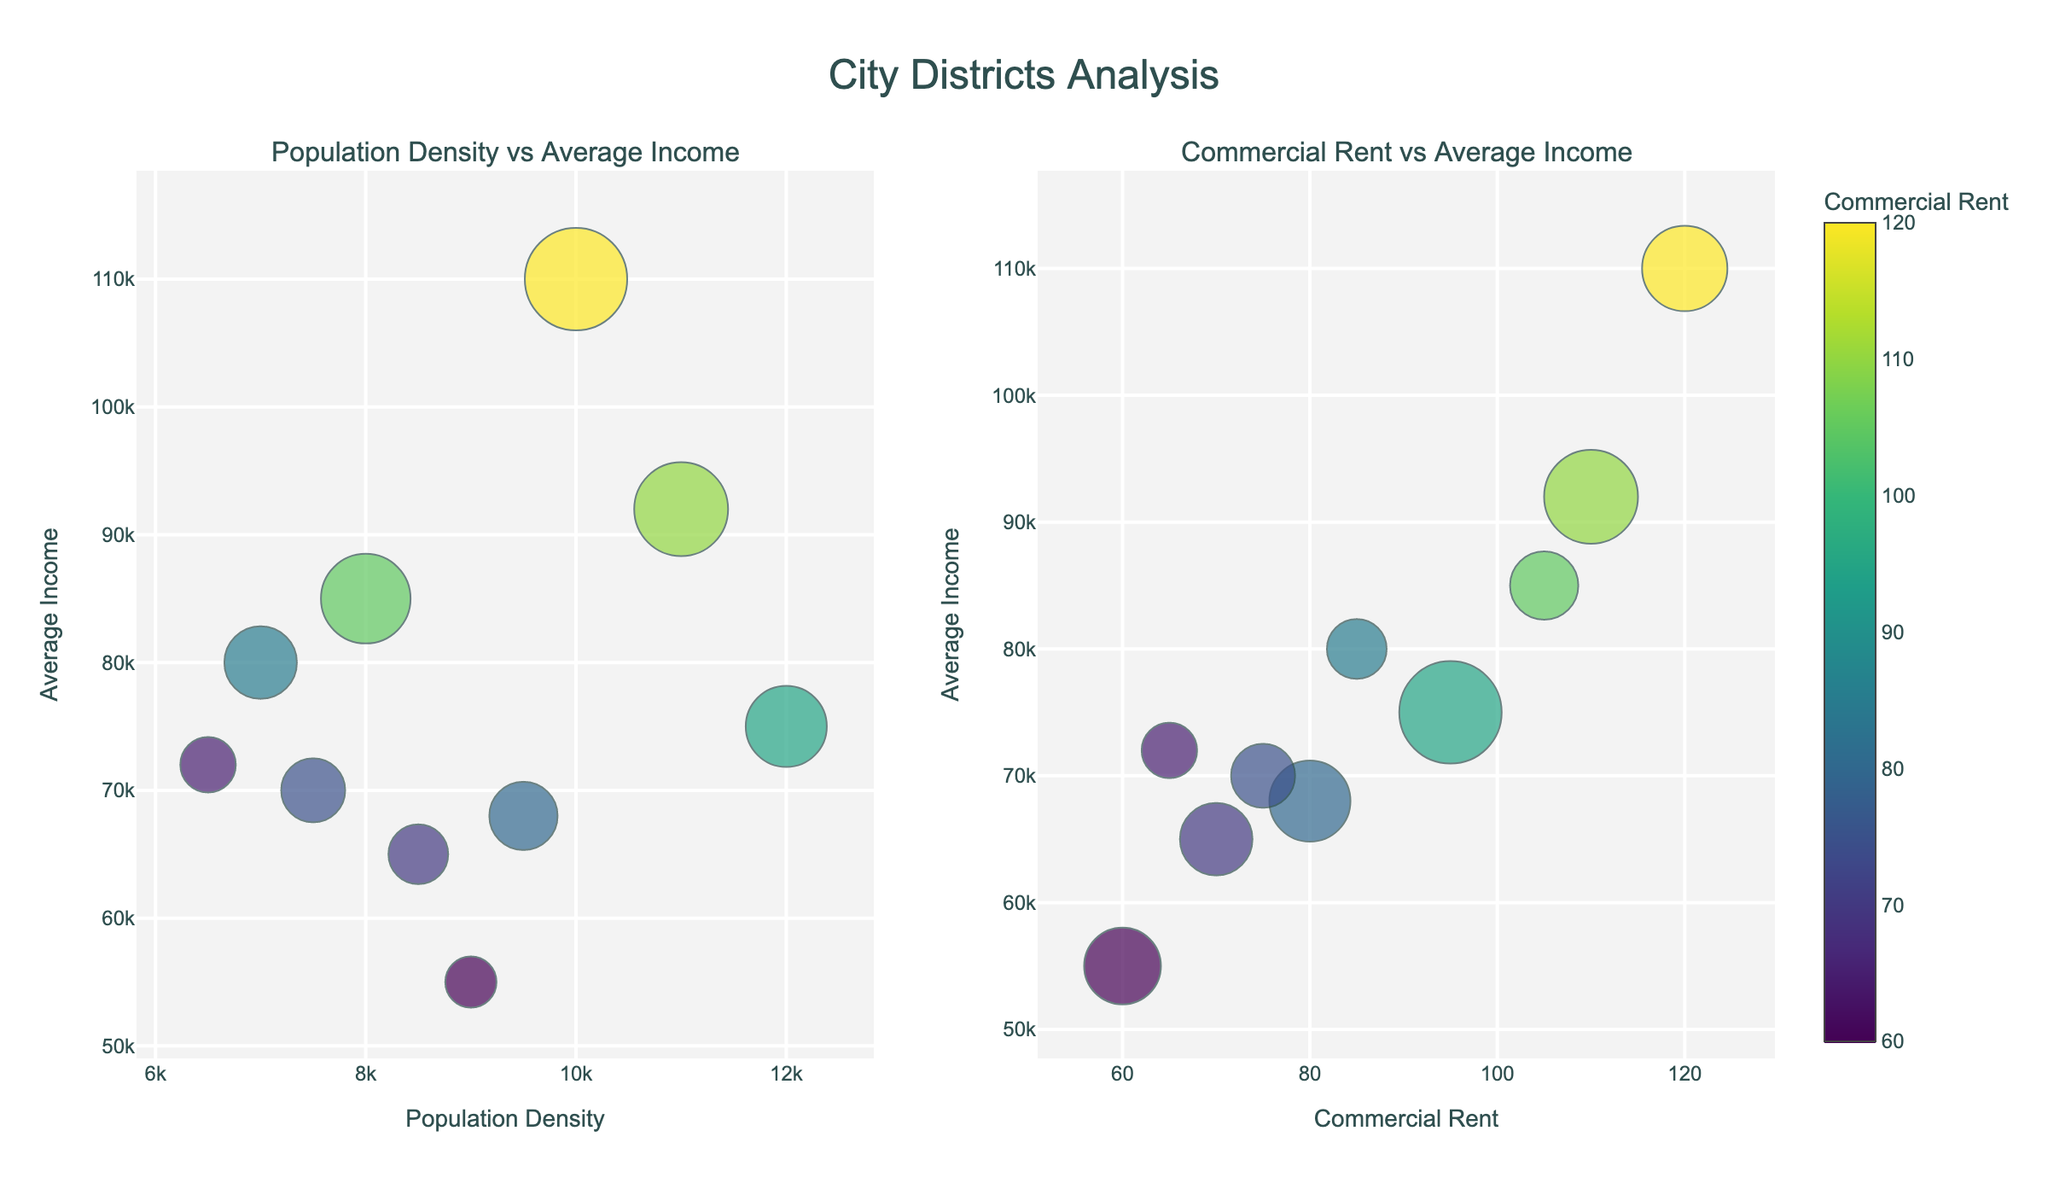what does the title of the figure say? The title is located at the top center of the figure. It provides context for the visualizations present. The title indicates that the figure is an analysis of various city districts.
Answer: City Districts Analysis How many subplots are there in the figure? Observing the layout, there are two distinct plots side by side within the figure.
Answer: 2 Which district has the highest population density? By examining the x-axis of the first subplot for the maximum population density value, we can see which data point is labeled as "District." The point with the highest x-axis value and the label "Downtown" corresponds to the highest population density.
Answer: Downtown Which subplot shows the relationship between Commercial Rent and Average Income? The labels for the axes are key. By observing the subplot where the x-axis is titled "Commercial Rent" and y-axis is titled "Average Income," you can identify it as the second subplot (right side).
Answer: The second subplot What is the average income for the Financial District? Hovering over or identifying the specific data point labeled "Financial District" in either subplot and checking the y-axis value will show the average income.
Answer: 92,000 Which district has the smallest bubble size in the first subplot, and what does this indicate about its Commercial Rent? Smaller bubble sizes in the first subplot represent lower commercial rent. By identifying the smallest bubble and its associated district label, we find that Long Island City has the smallest bubble size, indicating it has the lowest Commercial Rent.
Answer: Long Island City How does the Average Income in Chelsea compare to that in Williamsburg? Using either subplot, find the y-axis values for Chelsea and Williamsburg. Compare these values to determine that Williamsburg has a lower average income compared to Chelsea.
Answer: Chelsea has a higher average income than Williamsburg Which district appears to be an anomaly based on its position in the Commercial Rent vs. Average Income subplot? Identifying data points that don't fit the overall trend requires looking for outliers. The Upper East Side stands out because of its very high average income compared to its commercial rent.
Answer: Upper East Side Which district has the highest Commercial Rent, and how does its Average Income compare to other districts? In the second subplot, locate the data point with the highest x-axis value, labeled "Upper East Side." Its y-axis value represents its average income, which is the highest, so it compares very high relative to all other districts.
Answer: Upper East Side's Average Income is very high compared to other districts 